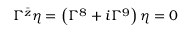Convert formula to latex. <formula><loc_0><loc_0><loc_500><loc_500>\Gamma ^ { \bar { z } } \eta = \left ( \Gamma ^ { 8 } + i \Gamma ^ { 9 } \right ) \eta = 0</formula> 